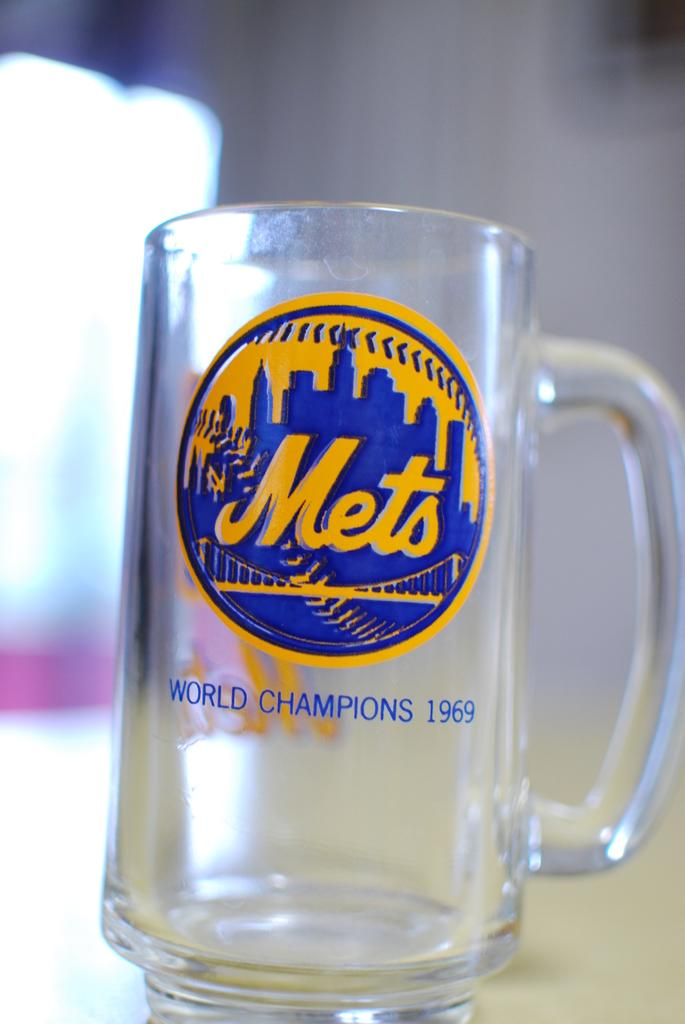What object is present in the image that can hold a liquid? There is a glass in the image. Is there any text or label on the glass? Yes, the glass has the name "Metz" on it. How many boys are playing in the snow on the page of the book in the image? There is no book, page, or boys playing in the snow present in the image. 